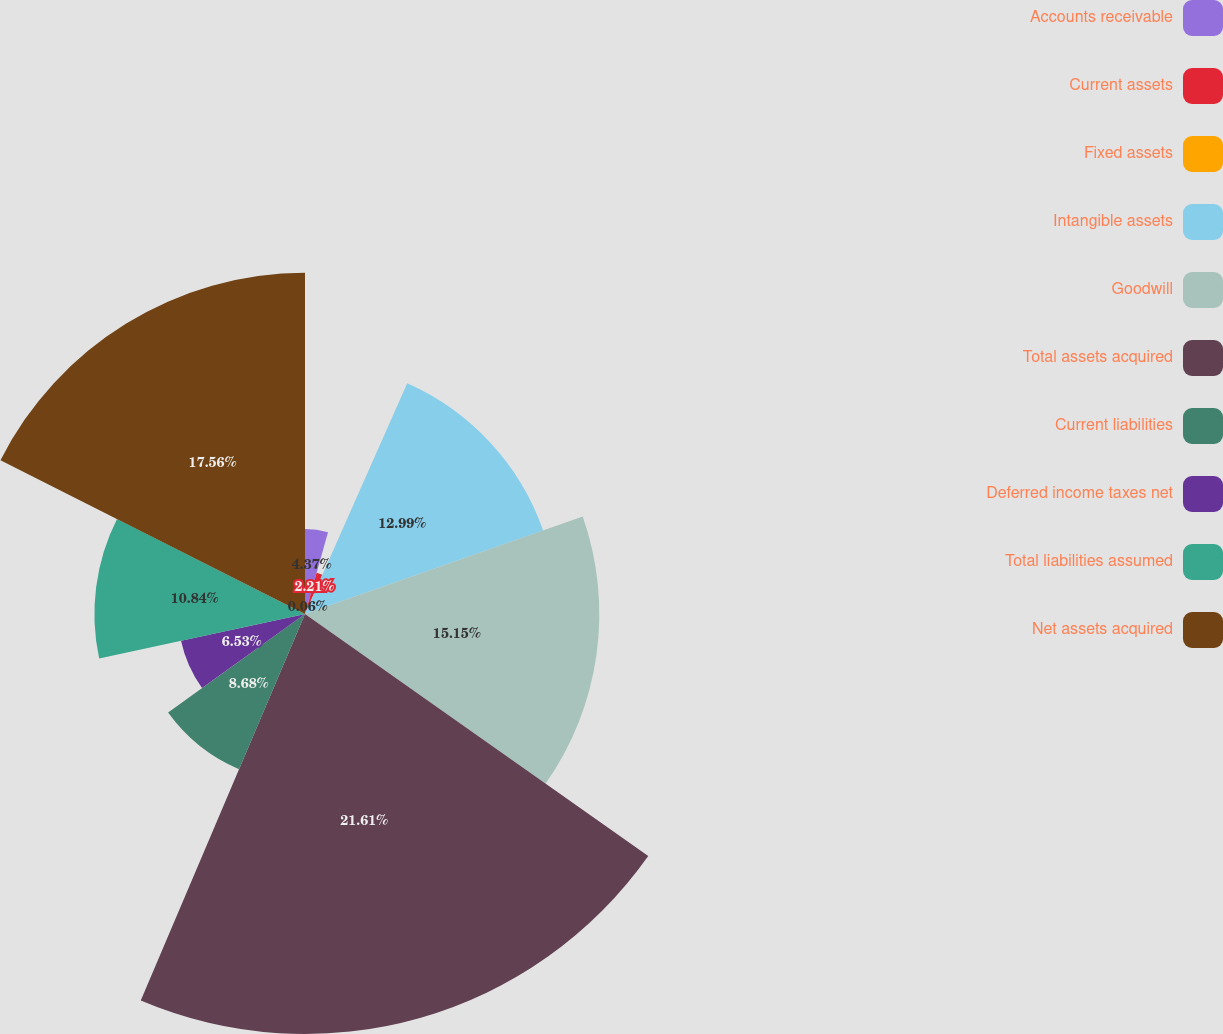Convert chart. <chart><loc_0><loc_0><loc_500><loc_500><pie_chart><fcel>Accounts receivable<fcel>Current assets<fcel>Fixed assets<fcel>Intangible assets<fcel>Goodwill<fcel>Total assets acquired<fcel>Current liabilities<fcel>Deferred income taxes net<fcel>Total liabilities assumed<fcel>Net assets acquired<nl><fcel>4.37%<fcel>2.21%<fcel>0.06%<fcel>12.99%<fcel>15.15%<fcel>21.62%<fcel>8.68%<fcel>6.53%<fcel>10.84%<fcel>17.56%<nl></chart> 